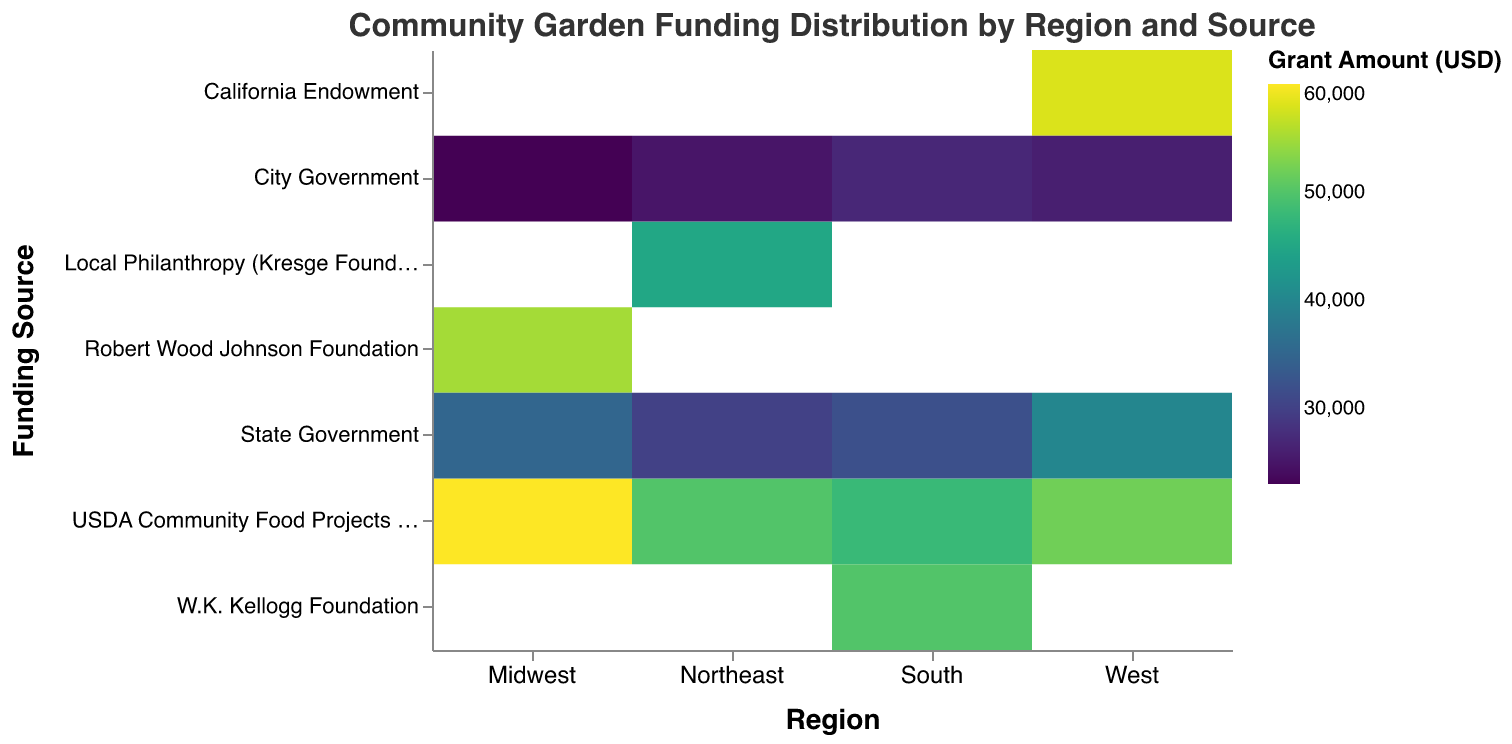What region receives the largest grant from the USDA Community Food Projects Competitive Grant Program? To determine this, locate the cells corresponding to the USDA Community Food Projects Competitive Grant Program for each region. Compare the grant amounts, noting that the Midwest has the largest amount at USD 60,000.
Answer: Midwest Which funding source provides the highest amount of grants in the West region? Observe the cells in the West region row, and compare the grant amounts. The California Endowment provides the highest amount with USD 58,000.
Answer: California Endowment How much is the total grant amount provided by city governments across all regions? Add the grant amounts provided by city governments in each region: USD 25,000 (Northeast), USD 23,000 (Midwest), USD 27,000 (South), and USD 26,000 (West). The total is USD 25,000 + 23,000 + 27,000 + 26,000 = USD 101,000.
Answer: 101,000 Which region receives the least amount of funding from the state government? Examine the cells corresponding to the State Government funding source for each region. The Northeast receives the least amount at USD 30,000.
Answer: Northeast What is the average grant amount provided across all funding sources in the South region? To determine the average, add up all the grant amounts in the South region (USD 48,000 + 50,000 + 32,000 + 27,000) and divide by the number of funding sources (4). The total is 157,000 and the average is 157,000 / 4 = USD 39,250.
Answer: 39,250 Which foundation provides the highest grant amount across all regions? Compare the grant amounts of the foundations across all regions: Local Philanthropy (Kresge Foundation), Robert Wood Johnson Foundation, W.K. Kellogg Foundation, and California Endowment. The California Endowment provides the highest amount at USD 58,000.
Answer: California Endowment In which region does the W.K. Kellogg Foundation fund community gardens, and what is the grant amount? Locate the cell with the W.K. Kellogg Foundation funding source. The South region receives USD 50,000 from this foundation.
Answer: South, 50,000 What is the total grant amount from the USDA Community Food Projects Competitive Grant Program across all regions? Sum the grant amounts from USDA Community Food Projects Competitive Grant Program for all regions: USD 50,000 (Northeast), USD 60,000 (Midwest), USD 48,000 (South), and USD 52,000 (West). The total is 50,000 + 60,000 + 48,000 + 52,000 = USD 210,000.
Answer: 210,000 Which region receives the highest total funding from all sources combined? Sum the grant amounts from all sources for each region and compare. The West has the highest total funding: 52,000 + 58,000 + 40,000 + 26,000 = USD 176,000.
Answer: West 